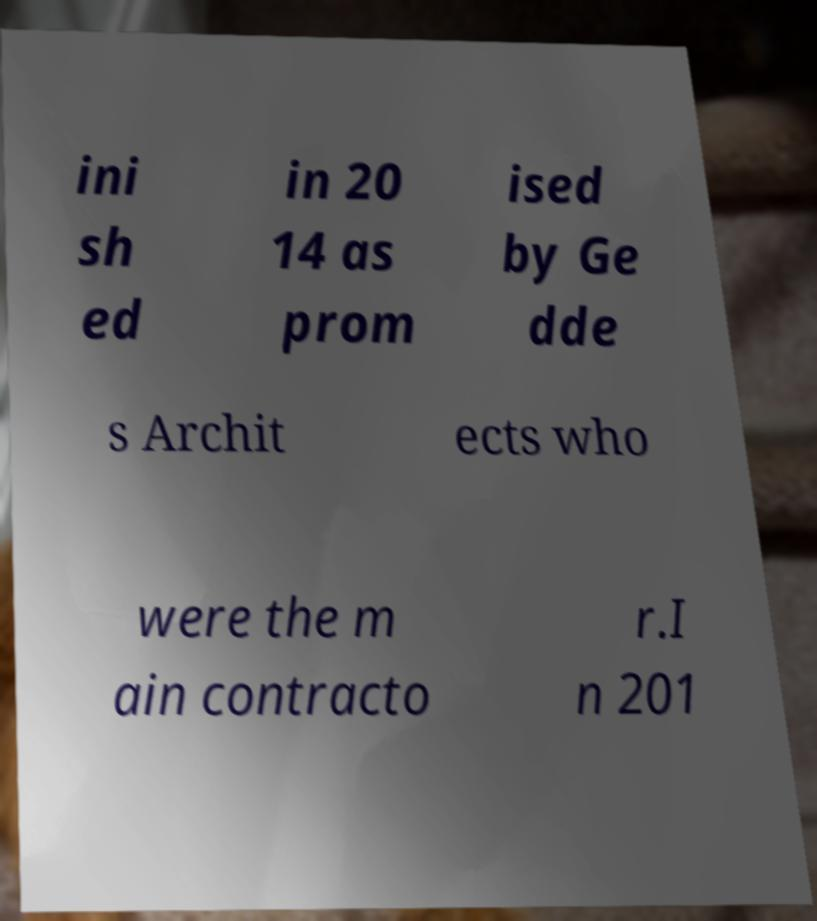I need the written content from this picture converted into text. Can you do that? ini sh ed in 20 14 as prom ised by Ge dde s Archit ects who were the m ain contracto r.I n 201 